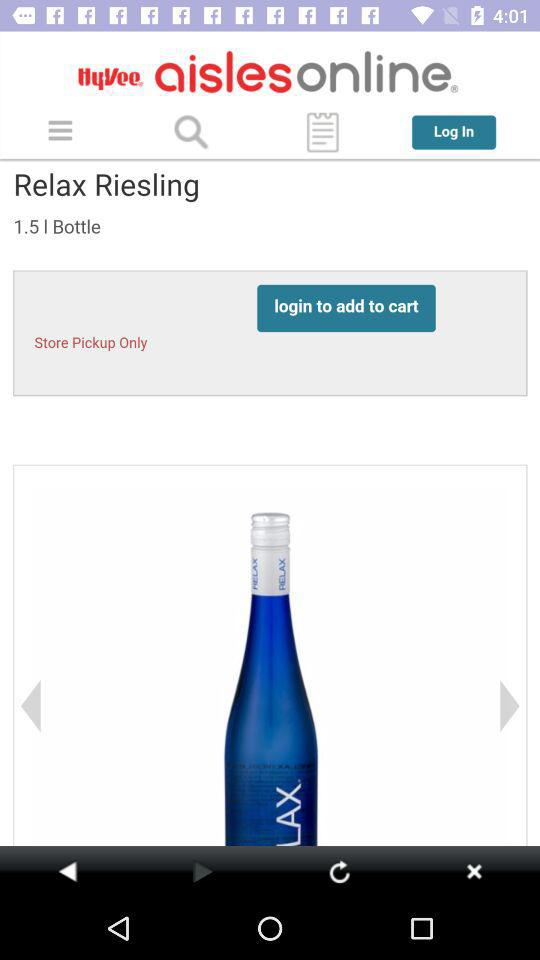What is the volume of the bottle in liters? The volume of the bottle in liters is 1.5. 